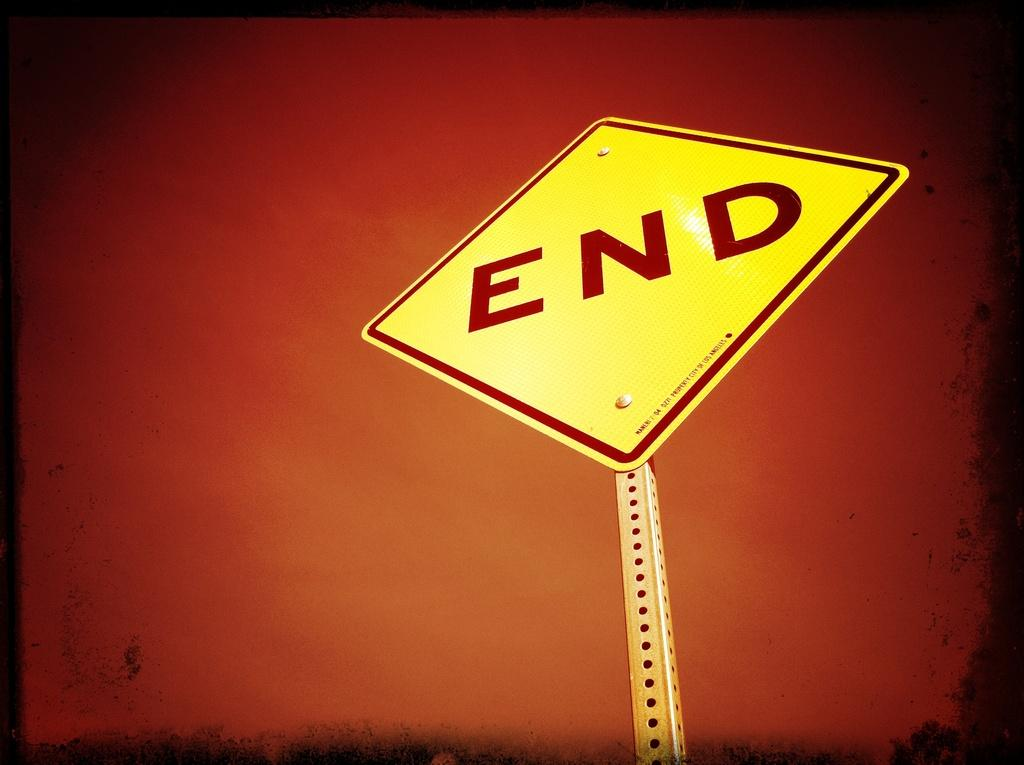Provide a one-sentence caption for the provided image. A yellow sign saying END is shown on a reddish faded dark background. 